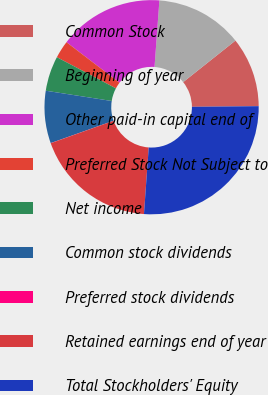Convert chart. <chart><loc_0><loc_0><loc_500><loc_500><pie_chart><fcel>Common Stock<fcel>Beginning of year<fcel>Other paid-in capital end of<fcel>Preferred Stock Not Subject to<fcel>Net income<fcel>Common stock dividends<fcel>Preferred stock dividends<fcel>Retained earnings end of year<fcel>Total Stockholders' Equity<nl><fcel>10.53%<fcel>13.15%<fcel>15.78%<fcel>2.65%<fcel>5.27%<fcel>7.9%<fcel>0.02%<fcel>18.41%<fcel>26.29%<nl></chart> 